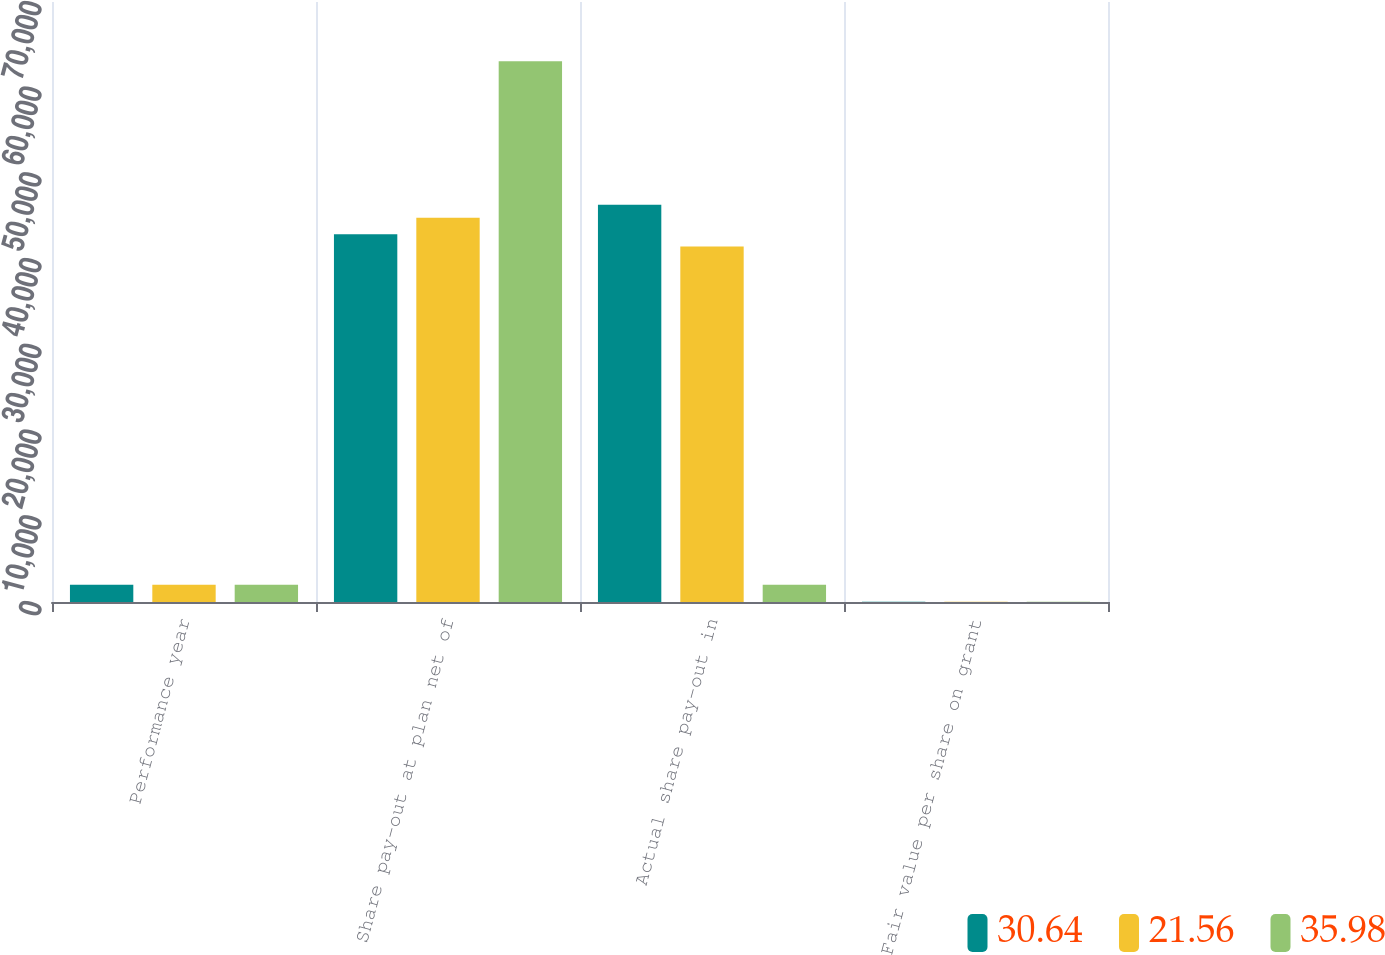<chart> <loc_0><loc_0><loc_500><loc_500><stacked_bar_chart><ecel><fcel>Performance year<fcel>Share pay-out at plan net of<fcel>Actual share pay-out in<fcel>Fair value per share on grant<nl><fcel>30.64<fcel>2013<fcel>42908<fcel>46340<fcel>35.98<nl><fcel>21.56<fcel>2012<fcel>44843<fcel>41481<fcel>30.64<nl><fcel>35.98<fcel>2011<fcel>63102<fcel>2013<fcel>21.56<nl></chart> 